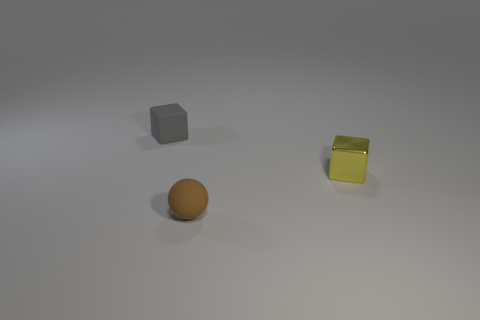Add 3 yellow metal blocks. How many objects exist? 6 Subtract all yellow blocks. How many blocks are left? 1 Subtract all spheres. How many objects are left? 2 Subtract 2 blocks. How many blocks are left? 0 Add 2 matte objects. How many matte objects are left? 4 Add 1 yellow objects. How many yellow objects exist? 2 Subtract 1 brown balls. How many objects are left? 2 Subtract all yellow spheres. Subtract all yellow cubes. How many spheres are left? 1 Subtract all gray cylinders. How many cyan blocks are left? 0 Subtract all small purple metal balls. Subtract all tiny rubber things. How many objects are left? 1 